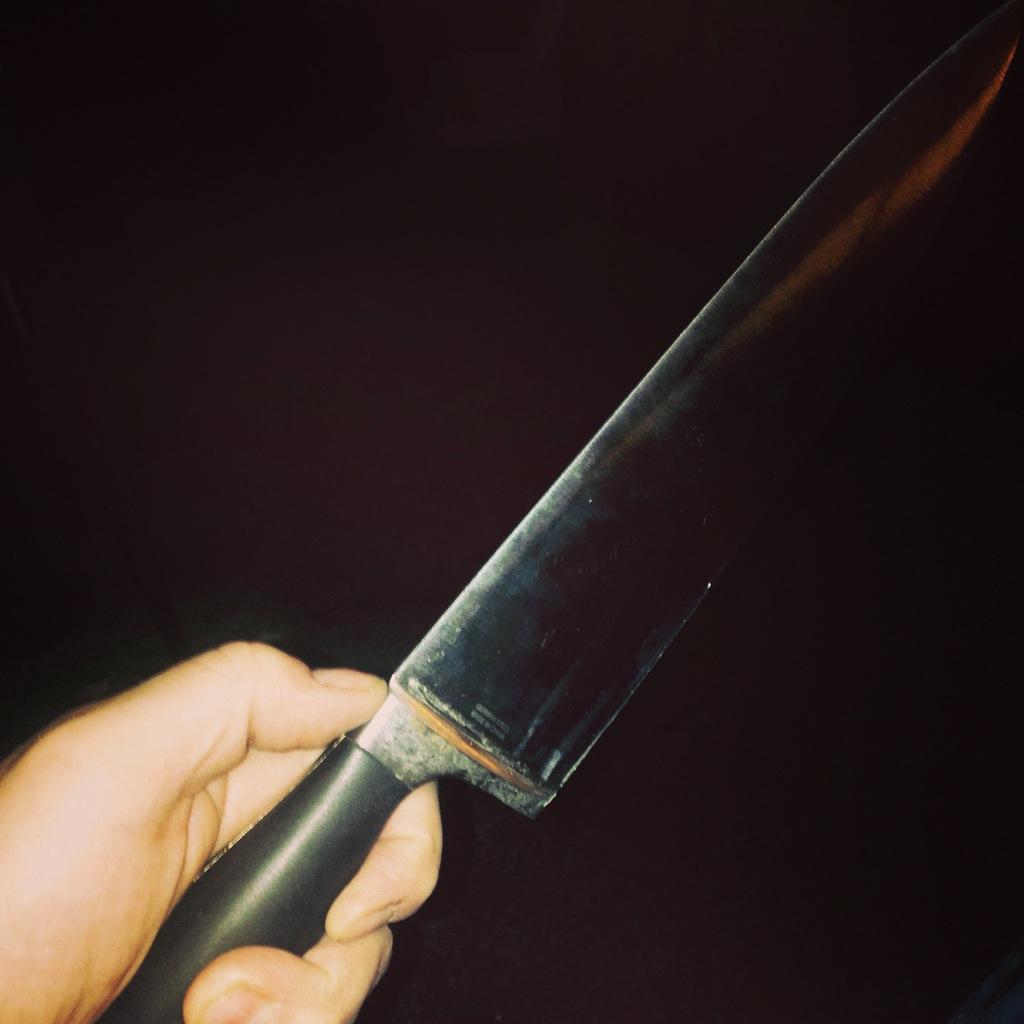Please provide a concise description of this image. In this picture we can see a person is holding a knife. 